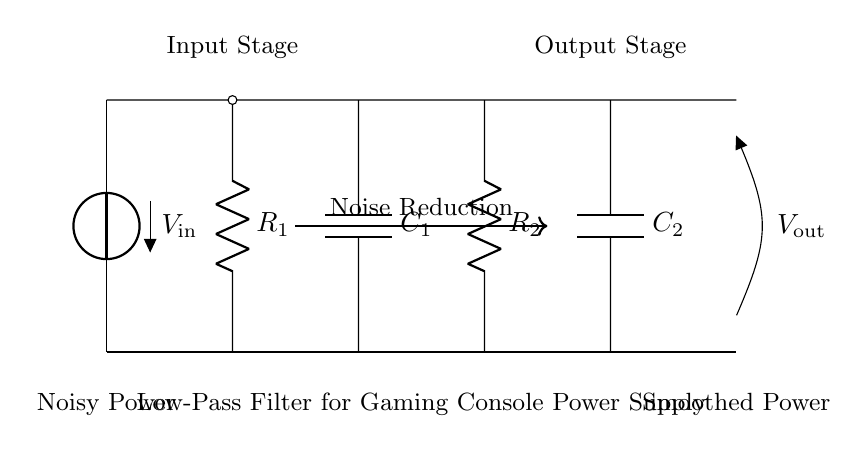What is the input voltage of the circuit? The input voltage is indicated as V_in (input stage) in the diagram. It is the potential difference at the starting point of the circuit.
Answer: V_in What type of components are used in this filter circuit? The components in this low-pass filter include resistors and capacitors, specifically R1, R2, C1, and C2 as shown in the diagram.
Answer: Resistors and capacitors What is the output voltage of the circuit? The output voltage is indicated as V_out (output stage) at the end of the circuit, where the output is taken after smoothing.
Answer: V_out What is the purpose of this filter circuit? The function of the filter circuit is to reduce noise, which is detailed in the diagram labeling and the arrows indicating noise reduction between stages.
Answer: Noise reduction How many resistors are present in this low-pass filter? Inspecting the circuit diagram shows there are two resistors, labeled R1 and R2.
Answer: Two What is the relationship between the components R1, C1, R2, and C2 in this filter? The combination of these resistors and capacitors determines the filtering characteristics, specifically the cutoff frequency, through their respective series and parallel connections throughout the circuit diagram.
Answer: Cutoff frequency What does the arrow labeled "Noise Reduction" indicate in this circuit? The arrow signifies the function of the circuit, highlighting that the path between the input and output is intended to reduce fluctuations or noise in the power supply.
Answer: Smoothing effect 